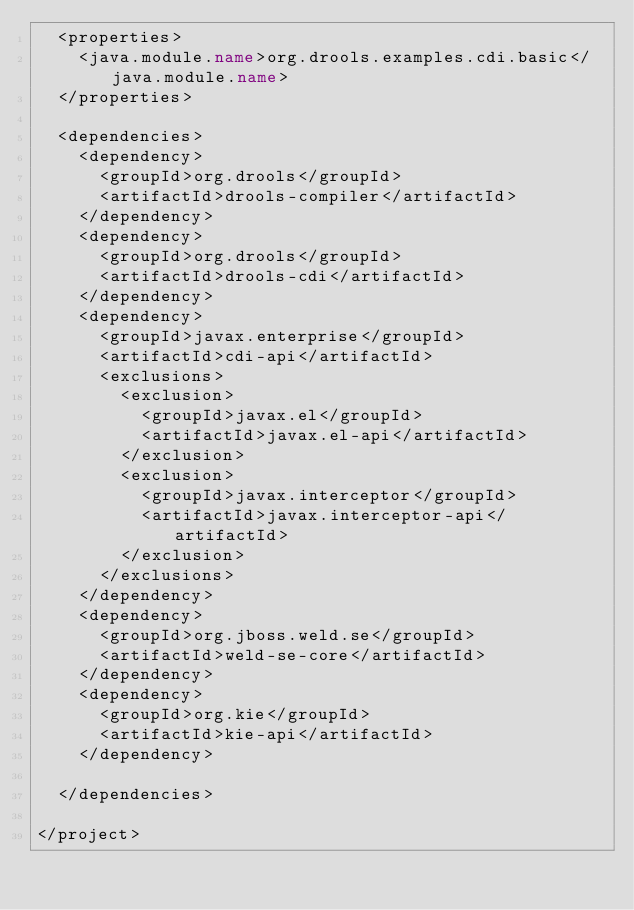Convert code to text. <code><loc_0><loc_0><loc_500><loc_500><_XML_>  <properties>
    <java.module.name>org.drools.examples.cdi.basic</java.module.name>
  </properties>

  <dependencies>
    <dependency>
      <groupId>org.drools</groupId>
      <artifactId>drools-compiler</artifactId>
    </dependency>
    <dependency>
      <groupId>org.drools</groupId>
      <artifactId>drools-cdi</artifactId>
    </dependency>
    <dependency>
      <groupId>javax.enterprise</groupId>
      <artifactId>cdi-api</artifactId>
      <exclusions>
        <exclusion>
          <groupId>javax.el</groupId>
          <artifactId>javax.el-api</artifactId>
        </exclusion>
        <exclusion>
          <groupId>javax.interceptor</groupId>
          <artifactId>javax.interceptor-api</artifactId>
        </exclusion>
      </exclusions>
    </dependency>
    <dependency>
      <groupId>org.jboss.weld.se</groupId>
      <artifactId>weld-se-core</artifactId>
    </dependency>
    <dependency>
      <groupId>org.kie</groupId>
      <artifactId>kie-api</artifactId>
    </dependency>

  </dependencies>

</project>
</code> 